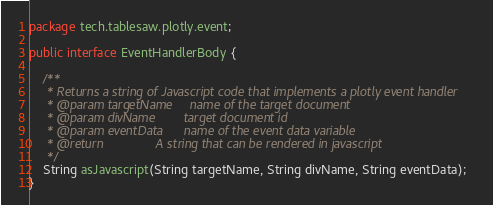Convert code to text. <code><loc_0><loc_0><loc_500><loc_500><_Java_>package tech.tablesaw.plotly.event;

public interface EventHandlerBody {

    /**
     * Returns a string of Javascript code that implements a plotly event handler
     * @param targetName     name of the target document
     * @param divName        target document id
     * @param eventData      name of the event data variable
     * @return               A string that can be rendered in javascript
     */
    String asJavascript(String targetName, String divName, String eventData);
}
</code> 